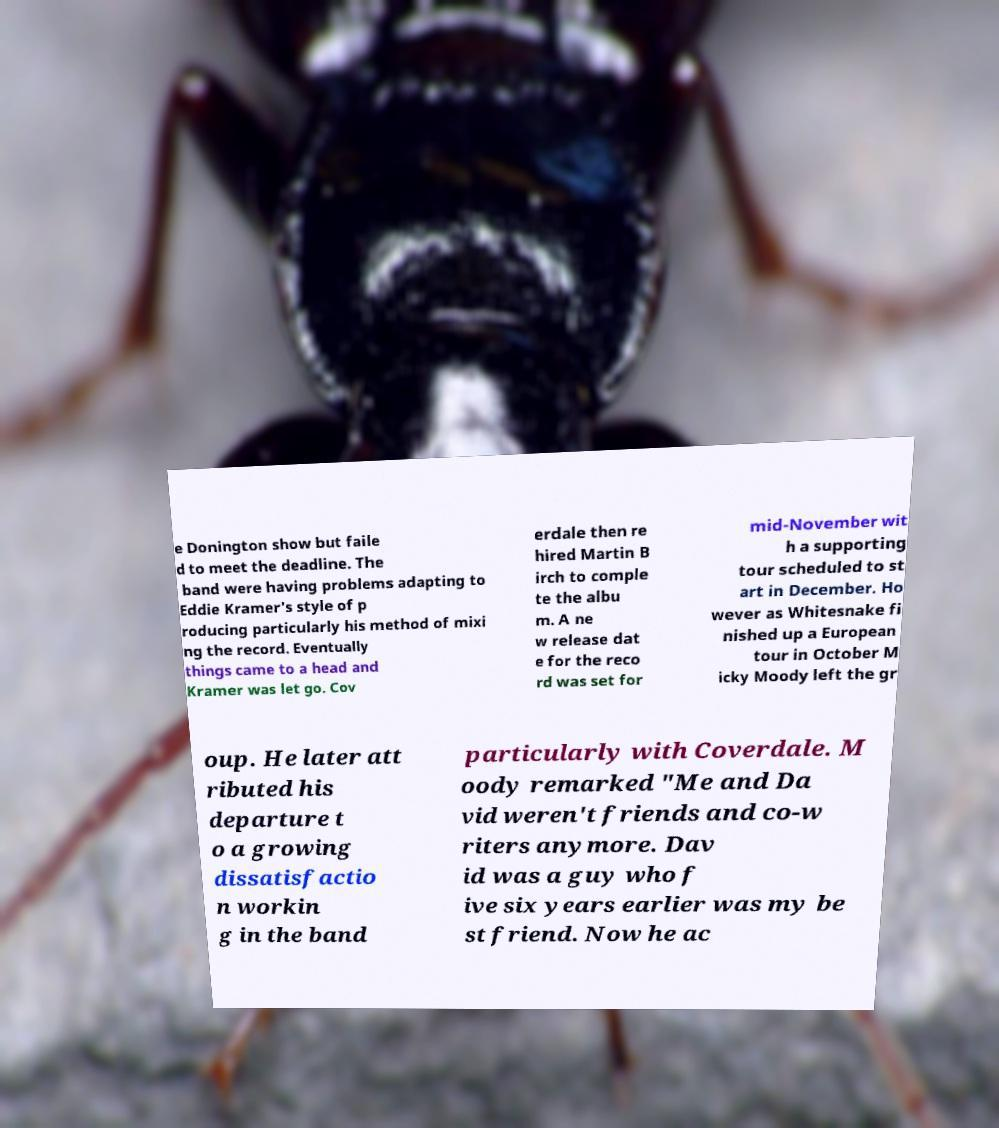I need the written content from this picture converted into text. Can you do that? e Donington show but faile d to meet the deadline. The band were having problems adapting to Eddie Kramer's style of p roducing particularly his method of mixi ng the record. Eventually things came to a head and Kramer was let go. Cov erdale then re hired Martin B irch to comple te the albu m. A ne w release dat e for the reco rd was set for mid-November wit h a supporting tour scheduled to st art in December. Ho wever as Whitesnake fi nished up a European tour in October M icky Moody left the gr oup. He later att ributed his departure t o a growing dissatisfactio n workin g in the band particularly with Coverdale. M oody remarked "Me and Da vid weren't friends and co-w riters anymore. Dav id was a guy who f ive six years earlier was my be st friend. Now he ac 